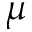<formula> <loc_0><loc_0><loc_500><loc_500>\mu</formula> 